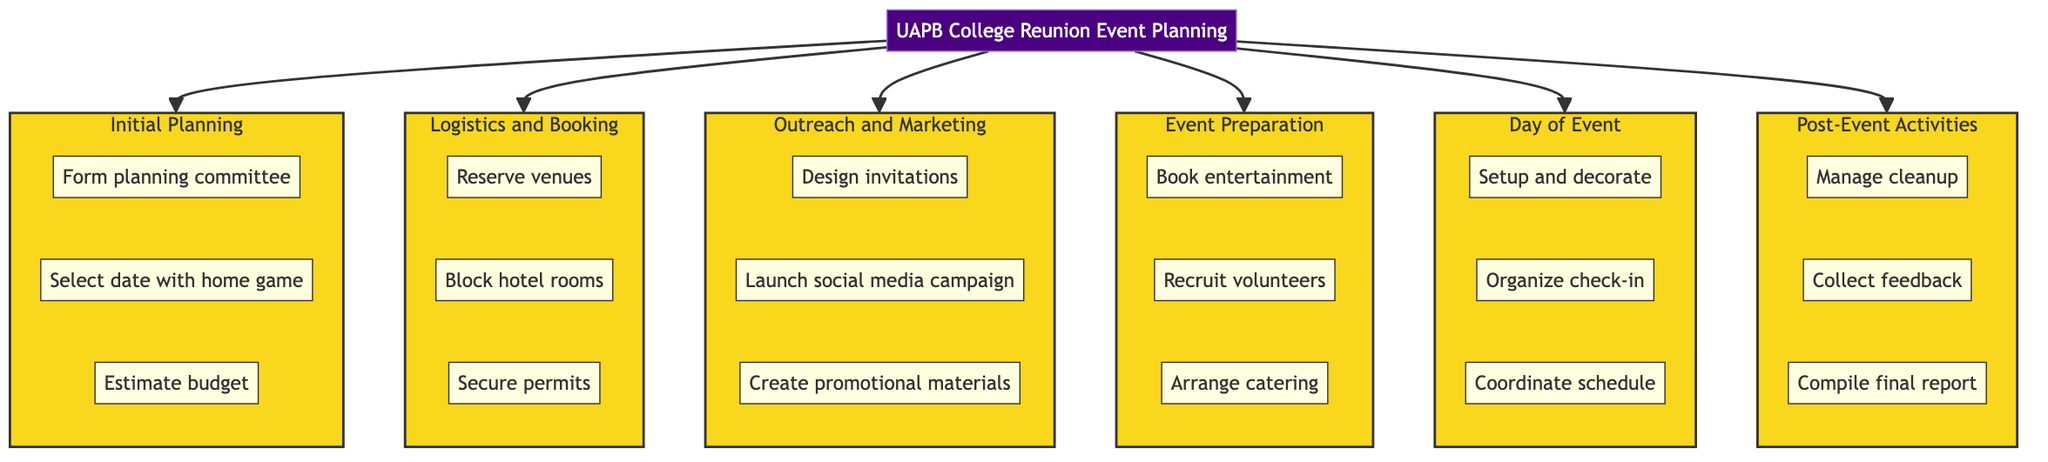What is the title of the event? The title node directly states "UAPB College Reunion Event Planning," which clearly identifies the main focus of the diagram.
Answer: UAPB College Reunion Event Planning How many phases are there in the event planning? By counting the number of major phases connected to the title in the diagram, we can identify six phases: Initial Planning, Logistics and Booking, Outreach and Marketing, Event Preparation, Day of Event, and Post-Event Activities.
Answer: 6 What is the first milestone in Phase 2? Phase 2 is labeled "Logistics and Booking," and the first milestone listed under this phase is "Reserve venues."
Answer: Reserve venues Which phase involves designing invitations? The milestone "Design invitations" falls under Phase 3, which is titled "Outreach and Marketing." By locating the relevant phase in the diagram, we can find the specific milestone associated with it.
Answer: Outreach and Marketing What is the last milestone in Phase 6? To determine the last milestone, we need to look at Phase 6 labeled "Post-Event Activities." The final milestone under this phase is "Compile final report." By examining the listed milestones, we can see this is indeed the last one.
Answer: Compile final report How many milestones are in Phase 4? Within Phase 4, labeled "Event Preparation," there are three specified milestones: "Book entertainment," "Recruit volunteers," and "Arrange catering." By counting these, we find there are three milestones in this phase.
Answer: 3 Which phase follows the "Initial Planning" phase? Following the arrangement of phases in the diagram, we identify that Phase 2, labeled "Logistics and Booking," comes directly after Phase 1, which is "Initial Planning." Therefore, this is the phase that follows.
Answer: Logistics and Booking What activities are included in the "Day of Event" phase? The "Day of Event" phase (Phase 5) consists of three milestones: "Setup and decorate," "Organize check-in," and "Coordinate schedule." By reviewing the milestones listed under this phase, we can discern the activities involved.
Answer: Setup and decorate, Organize check-in, Coordinate schedule What is the goal of the milestone "Collect feedback"? The milestone "Collect feedback" is part of Phase 6, labeled "Post-Event Activities." Its primary aim is to gather insights and responses from event attendees after the reunion to evaluate their experiences.
Answer: To gather insights from attendees 